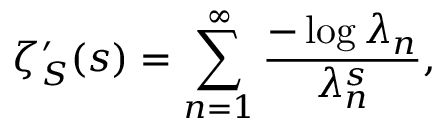Convert formula to latex. <formula><loc_0><loc_0><loc_500><loc_500>\zeta _ { S } ^ { \prime } ( s ) = \sum _ { n = 1 } ^ { \infty } { \frac { - \log \lambda _ { n } } { \lambda _ { n } ^ { s } } } ,</formula> 